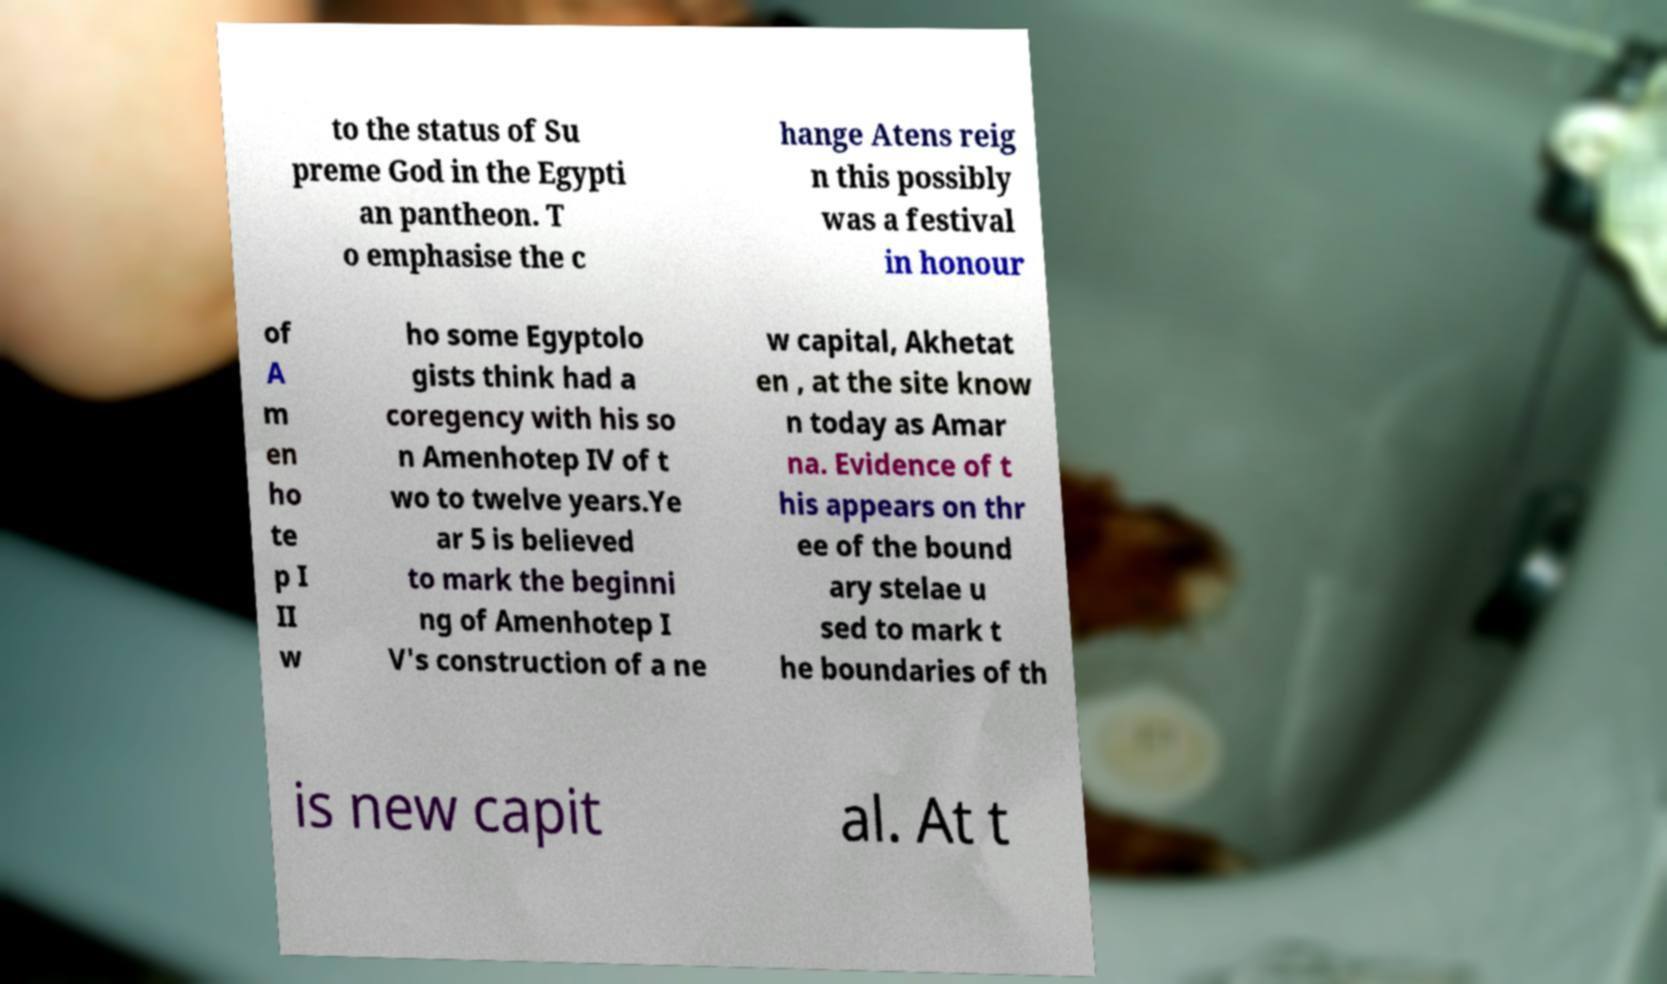There's text embedded in this image that I need extracted. Can you transcribe it verbatim? to the status of Su preme God in the Egypti an pantheon. T o emphasise the c hange Atens reig n this possibly was a festival in honour of A m en ho te p I II w ho some Egyptolo gists think had a coregency with his so n Amenhotep IV of t wo to twelve years.Ye ar 5 is believed to mark the beginni ng of Amenhotep I V's construction of a ne w capital, Akhetat en , at the site know n today as Amar na. Evidence of t his appears on thr ee of the bound ary stelae u sed to mark t he boundaries of th is new capit al. At t 